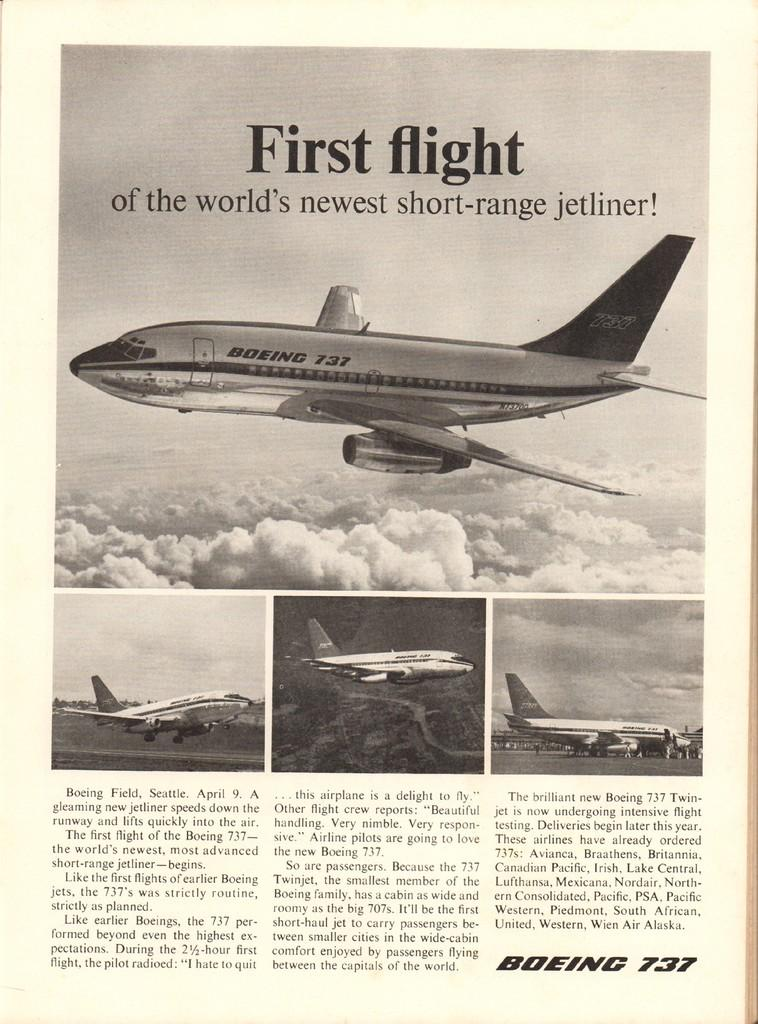What is the main subject of the paper in the image? The paper contains photos of airplanes. Are there any other elements on the paper besides the photos? Yes, there are words and numbers on the paper. How does the toe affect the rainstorm in the image? There is no toe or rainstorm present in the image. What type of crook is depicted in the image? There is no crook present in the image. 